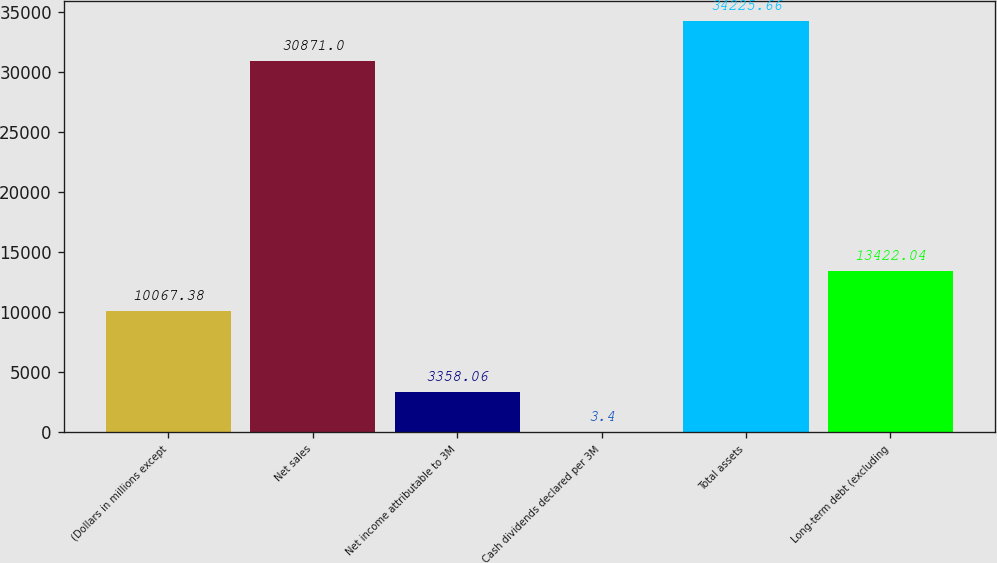Convert chart to OTSL. <chart><loc_0><loc_0><loc_500><loc_500><bar_chart><fcel>(Dollars in millions except<fcel>Net sales<fcel>Net income attributable to 3M<fcel>Cash dividends declared per 3M<fcel>Total assets<fcel>Long-term debt (excluding<nl><fcel>10067.4<fcel>30871<fcel>3358.06<fcel>3.4<fcel>34225.7<fcel>13422<nl></chart> 